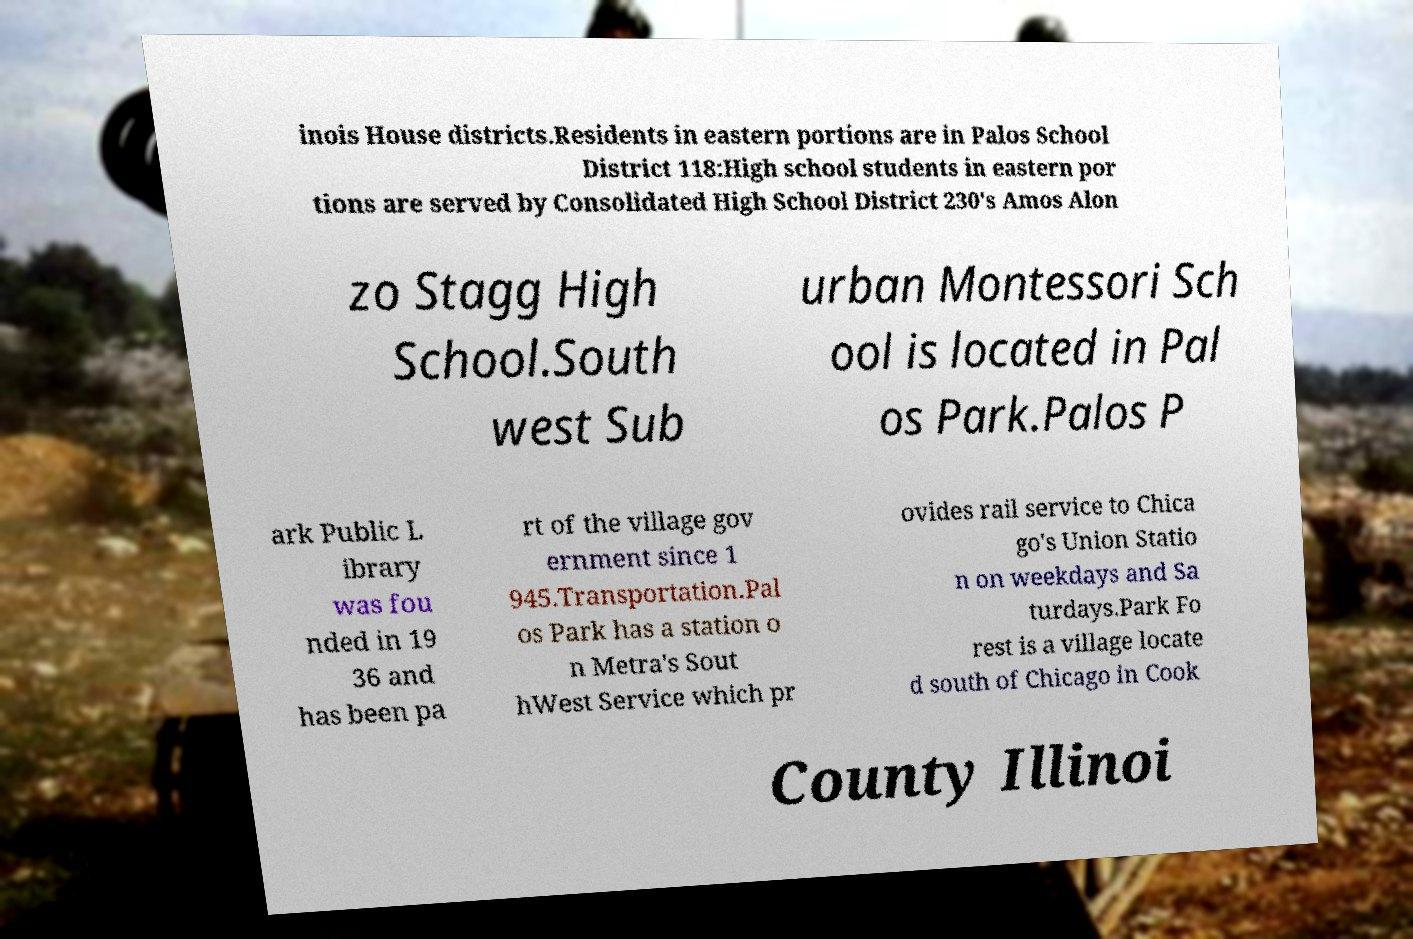For documentation purposes, I need the text within this image transcribed. Could you provide that? inois House districts.Residents in eastern portions are in Palos School District 118:High school students in eastern por tions are served by Consolidated High School District 230's Amos Alon zo Stagg High School.South west Sub urban Montessori Sch ool is located in Pal os Park.Palos P ark Public L ibrary was fou nded in 19 36 and has been pa rt of the village gov ernment since 1 945.Transportation.Pal os Park has a station o n Metra's Sout hWest Service which pr ovides rail service to Chica go's Union Statio n on weekdays and Sa turdays.Park Fo rest is a village locate d south of Chicago in Cook County Illinoi 